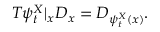Convert formula to latex. <formula><loc_0><loc_0><loc_500><loc_500>T \psi _ { t } ^ { X } | _ { x } D _ { x } = D _ { \psi _ { t } ^ { X } ( x ) } .</formula> 